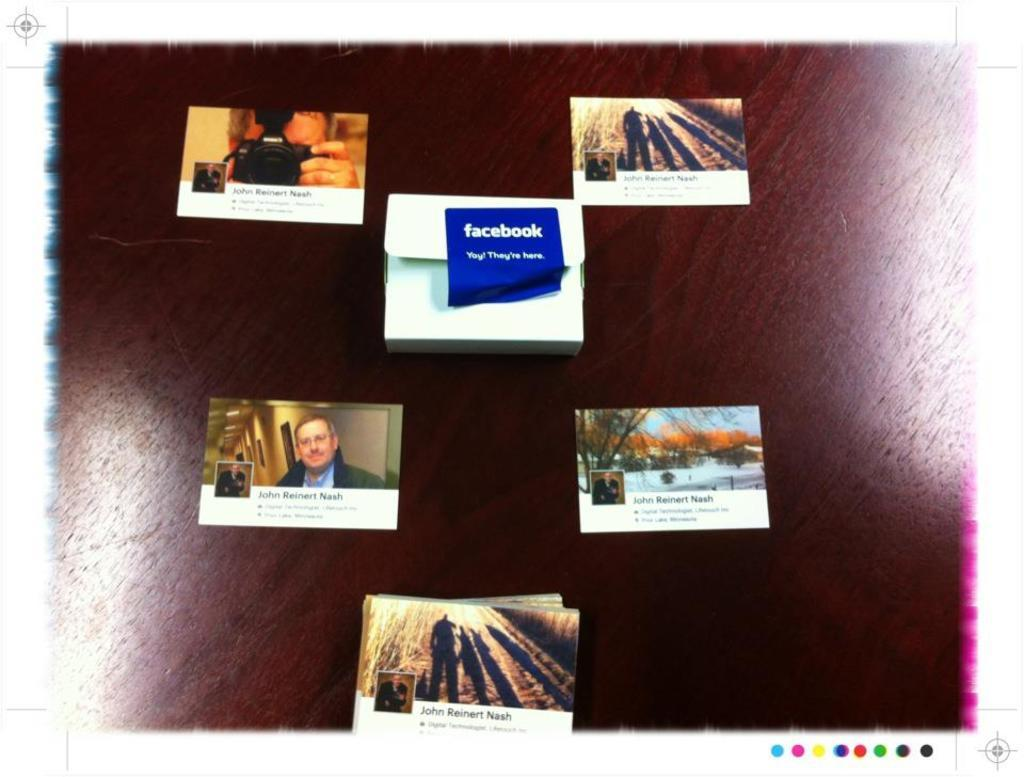<image>
Provide a brief description of the given image. An actual persons Facebook wall is laid out as separate pictures on a table. 